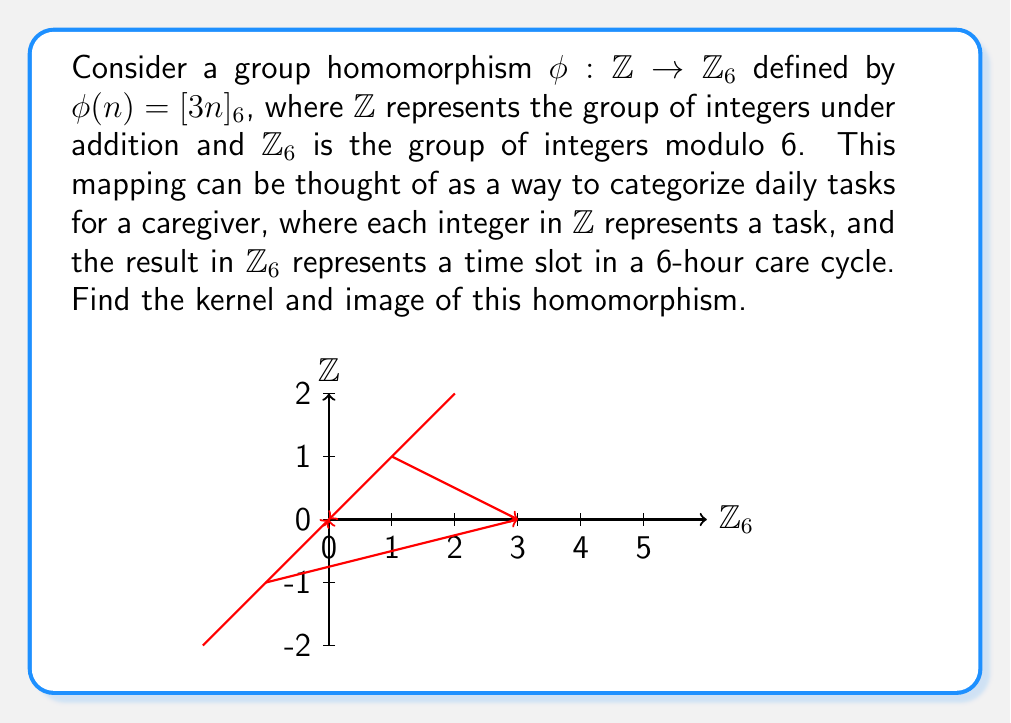Solve this math problem. Let's approach this step-by-step:

1) First, let's recall the definitions:
   - The kernel of a homomorphism $\phi$ is the set of all elements in the domain that map to the identity element in the codomain.
   - The image of a homomorphism $\phi$ is the set of all elements in the codomain that are mapped to by at least one element in the domain.

2) For $\mathbb{Z}_6$, the identity element is $[0]_6$.

3) To find the kernel, we need to solve the equation:
   $\phi(n) = [3n]_6 = [0]_6$

4) This is equivalent to solving:
   $3n \equiv 0 \pmod{6}$
   $n \equiv 0 \pmod{2}$

5) Therefore, the kernel consists of all even integers:
   $\text{ker}(\phi) = \{2k : k \in \mathbb{Z}\} = 2\mathbb{Z}$

6) To find the image, let's consider what values $[3n]_6$ can take:
   For $n = 0$: $[3 \cdot 0]_6 = [0]_6$
   For $n = 1$: $[3 \cdot 1]_6 = [3]_6$
   For $n = 2$: $[3 \cdot 2]_6 = [0]_6$
   For $n = 3$: $[3 \cdot 3]_6 = [3]_6$
   For $n = 4$: $[3 \cdot 4]_6 = [0]_6$
   For $n = 5$: $[3 \cdot 5]_6 = [3]_6$

7) We see that the image only contains $[0]_6$ and $[3]_6$:
   $\text{Im}(\phi) = \{[0]_6, [3]_6\}$
Answer: $\text{ker}(\phi) = 2\mathbb{Z}$, $\text{Im}(\phi) = \{[0]_6, [3]_6\}$ 